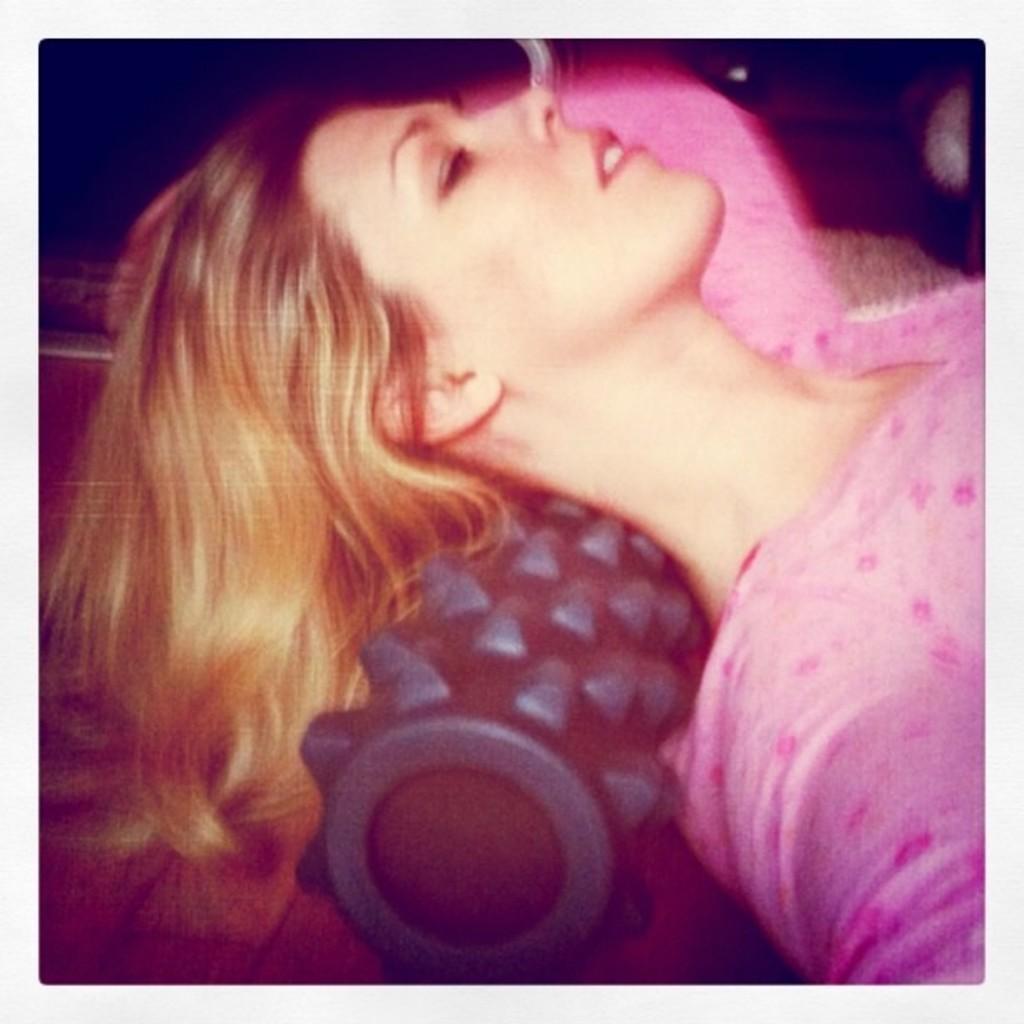Can you describe this image briefly? In this image we can see a picture in which we can see a woman lying on a roller. 